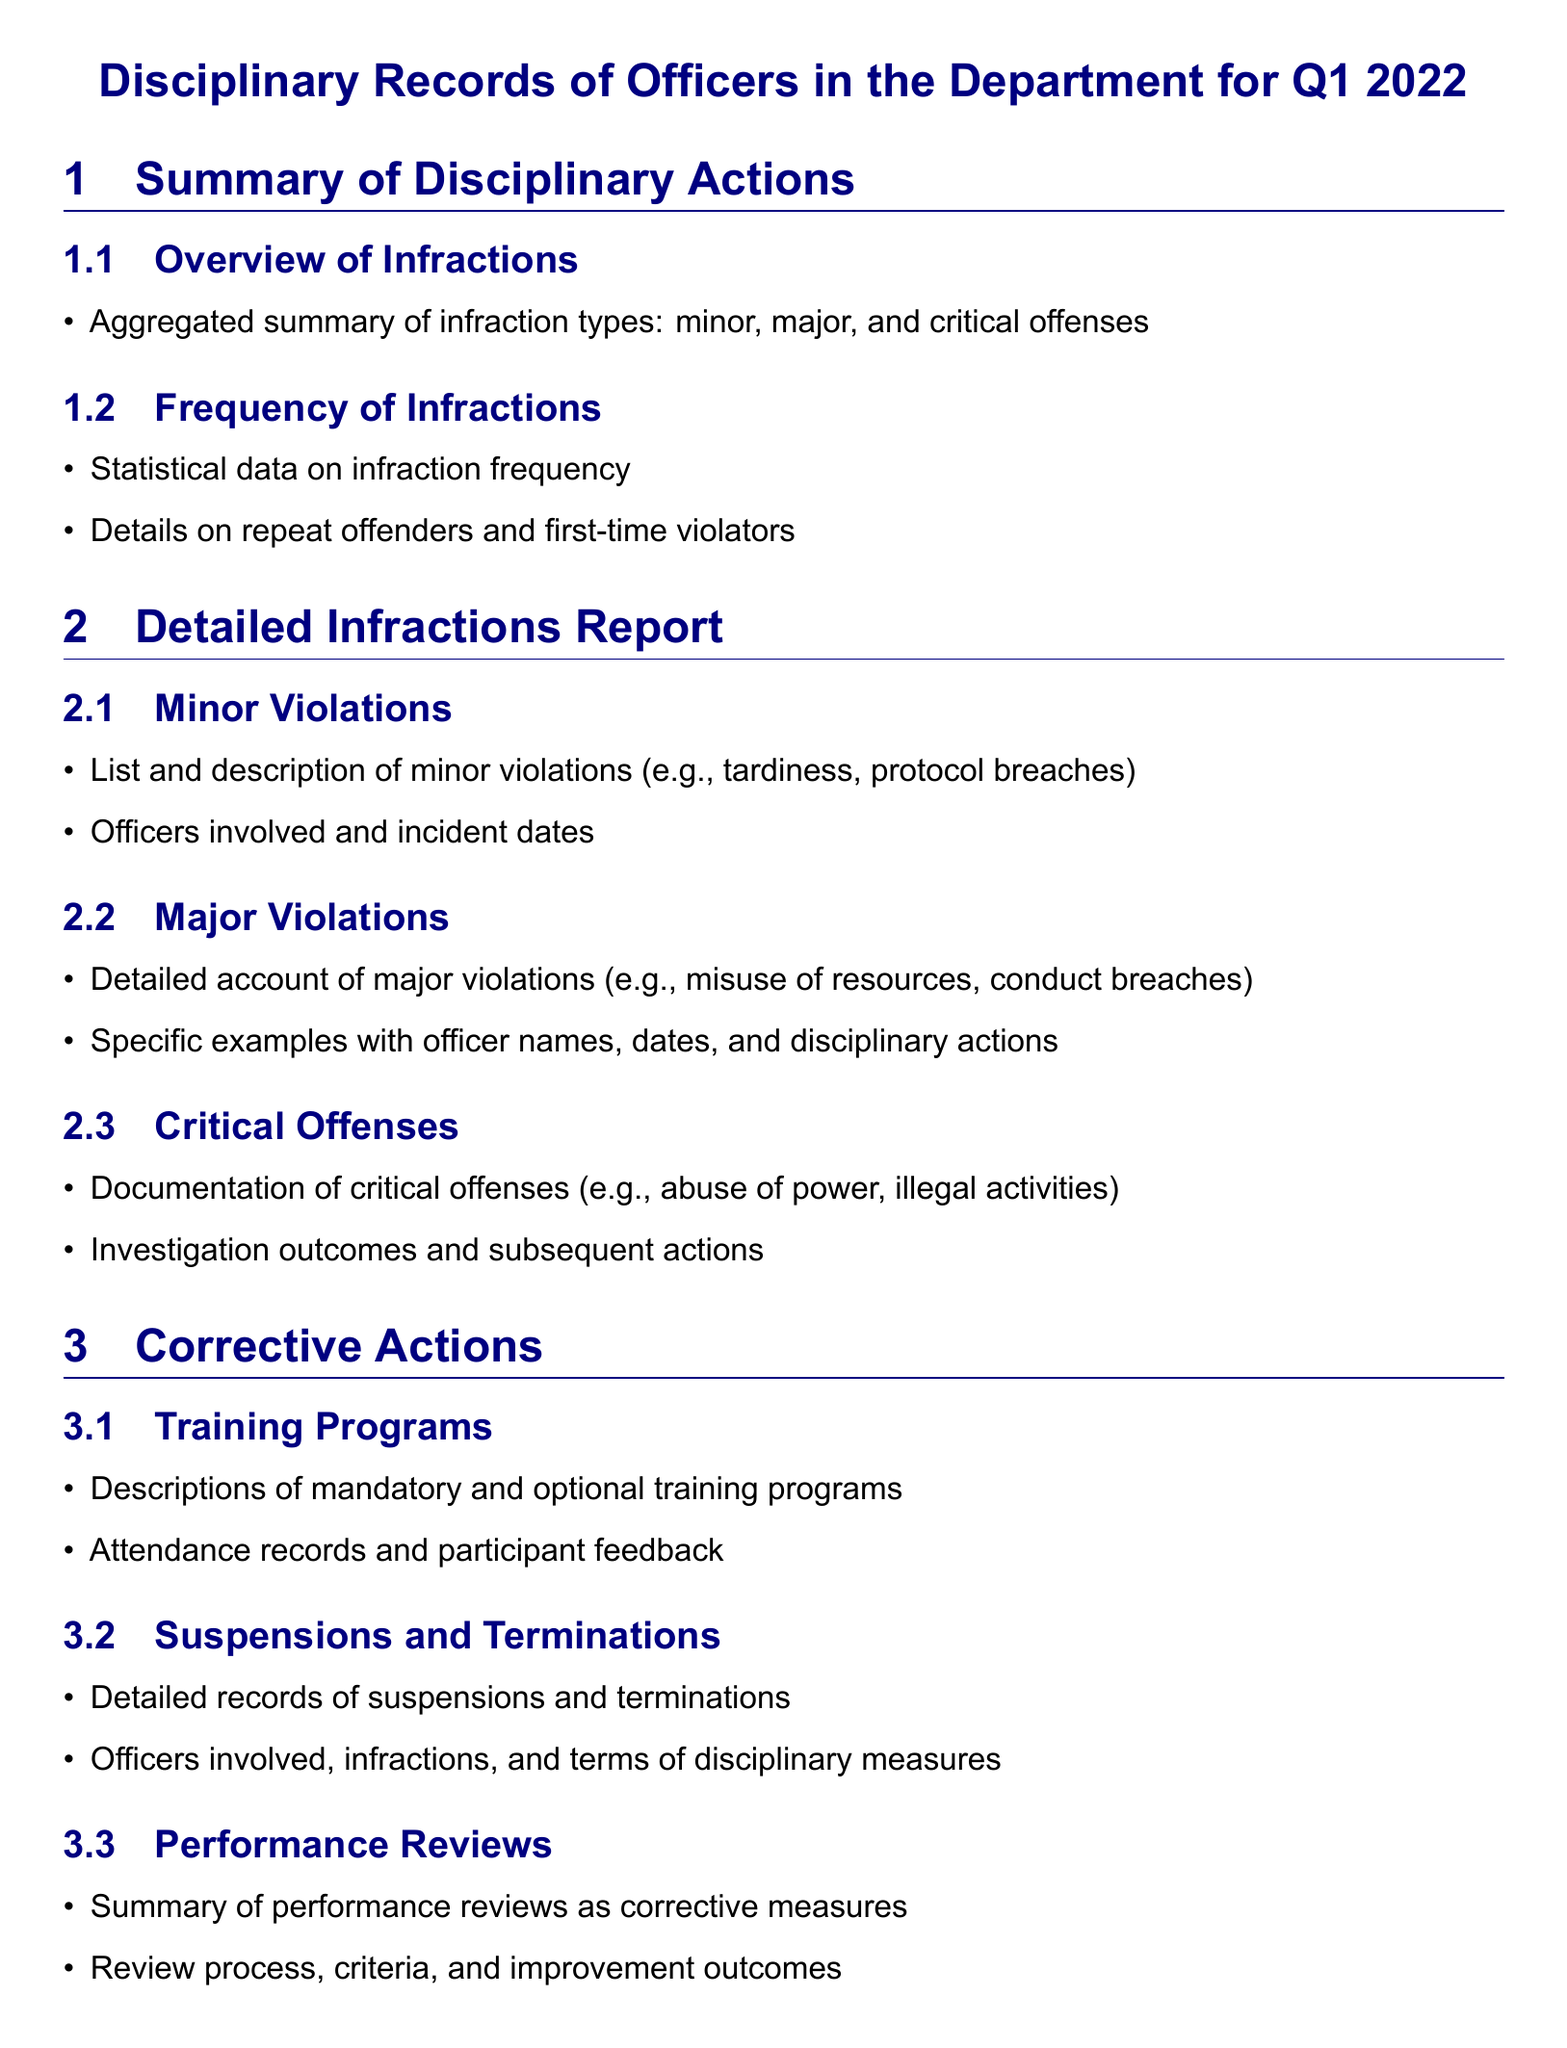what is the focus period of the disciplinary records? The disciplinary records are specifically for the first quarter of the year 2022.
Answer: Q1 2022 how many types of infractions are summarized? The document outlines three types of infractions: minor, major, and critical.
Answer: Three what types of violations are listed in the minor violations section? The minor violations include examples such as tardiness and protocol breaches.
Answer: Tardiness, protocol breaches which section details the outcomes of critical offenses? The investigation outcomes and subsequent actions of critical offenses are documented in the critical offenses section.
Answer: Critical Offenses what corrective action involves evaluations of officers? Performance reviews are utilized as a corrective measure for officers.
Answer: Performance reviews how are attendance records handled in the training programs? The attendance records are kept along with participant feedback for mandatory and optional training programs.
Answer: Attendance records what kind of record details suspensions and terminations? The detailed records of suspensions and terminations are provided in a specific subsection.
Answer: Suspensions and Terminations how are repeat offenders categorized in the document? Repeat offenders and first-time violators are mentioned in the frequency of infractions section.
Answer: Frequency of Infractions 